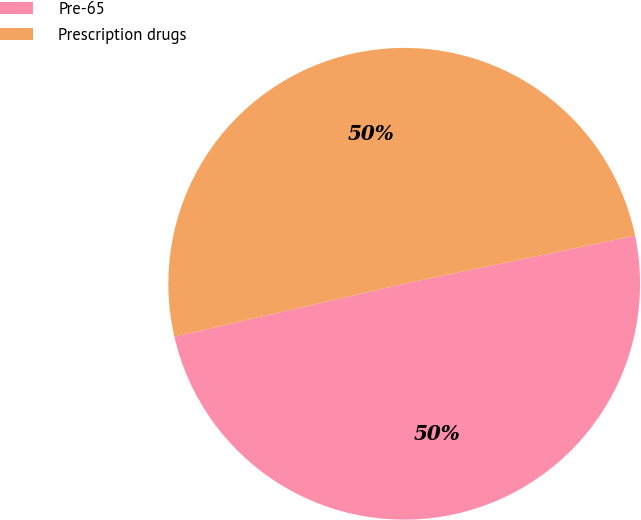Convert chart. <chart><loc_0><loc_0><loc_500><loc_500><pie_chart><fcel>Pre-65<fcel>Prescription drugs<nl><fcel>49.67%<fcel>50.33%<nl></chart> 